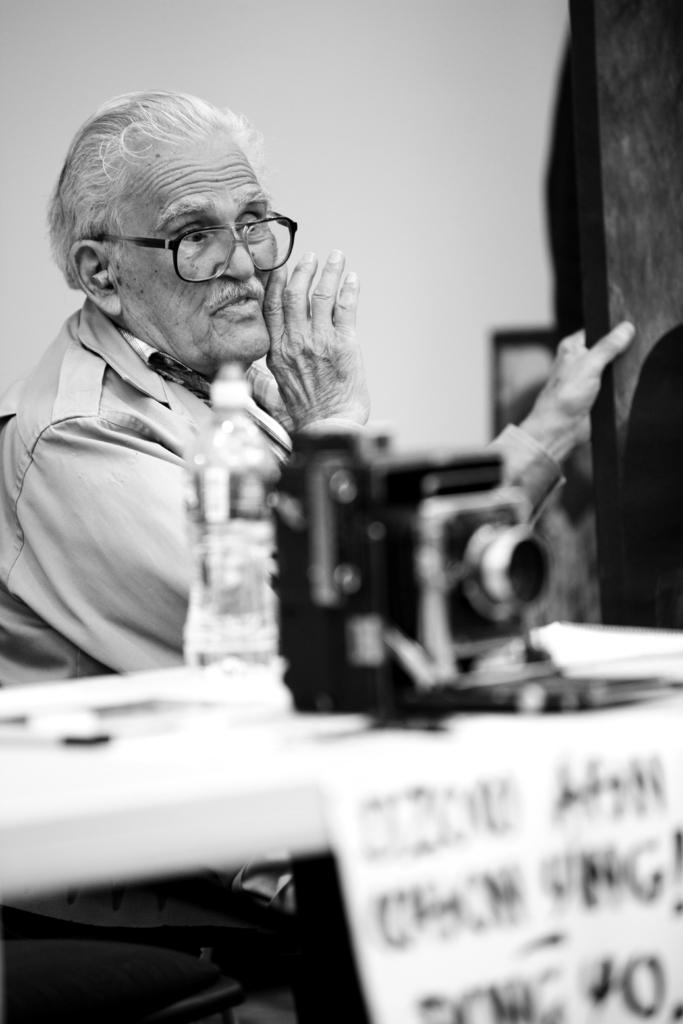How would you summarize this image in a sentence or two? In this image I can see the camera, bottle and few objects on the table. In the background I can see the person sitting and the image is in black and white. 